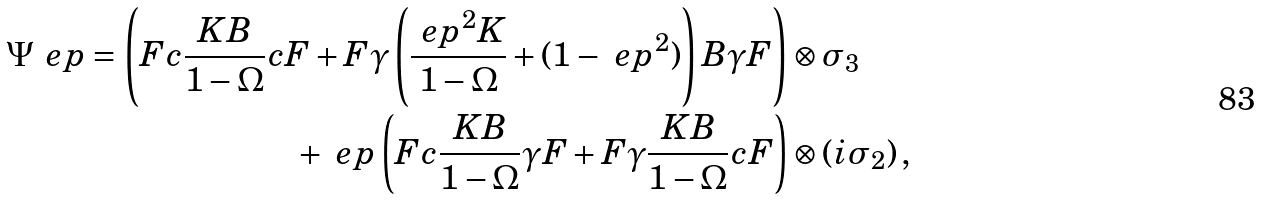Convert formula to latex. <formula><loc_0><loc_0><loc_500><loc_500>\Psi _ { \ } e p = \left ( F c \frac { K B } { 1 - \Omega } c F + F \gamma \left ( \frac { \ e p ^ { 2 } K } { 1 - \Omega } + ( 1 - \ e p ^ { 2 } ) \right ) B \gamma F \right ) & \otimes \sigma _ { 3 } \\ + \, \ e p \left ( F c \frac { K B } { 1 - \Omega } \gamma F + F \gamma \frac { K B } { 1 - \Omega } c F \right ) & \otimes ( i \sigma _ { 2 } ) \, ,</formula> 